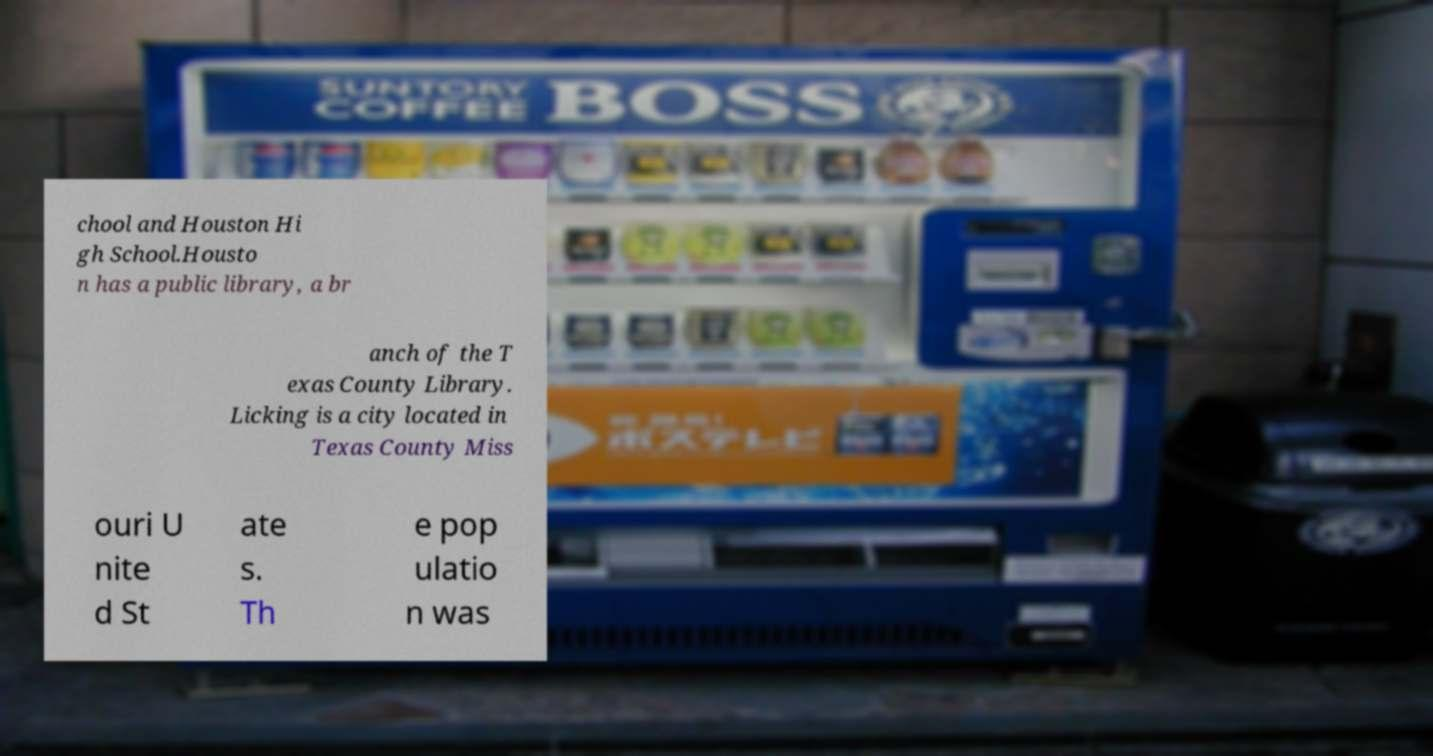For documentation purposes, I need the text within this image transcribed. Could you provide that? chool and Houston Hi gh School.Housto n has a public library, a br anch of the T exas County Library. Licking is a city located in Texas County Miss ouri U nite d St ate s. Th e pop ulatio n was 